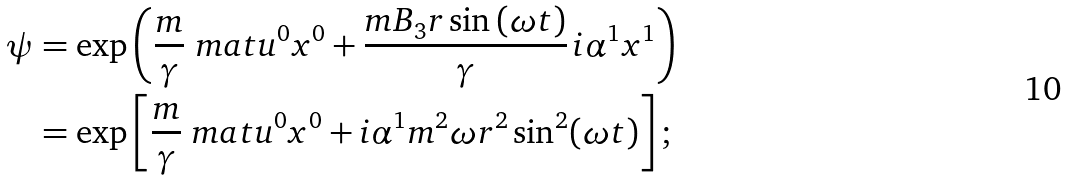<formula> <loc_0><loc_0><loc_500><loc_500>\psi & = \exp \left ( \frac { m } { \gamma } \ m a t { u } ^ { 0 } x ^ { 0 } + \frac { m B _ { 3 } r \sin \left ( \omega t \right ) } { \gamma } \, i \alpha ^ { 1 } x ^ { 1 } \right ) \\ & = \exp \left [ \frac { m } { \gamma } \ m a t { u } ^ { 0 } x ^ { 0 } + i \alpha ^ { 1 } m ^ { 2 } \omega r ^ { 2 } \sin ^ { 2 } ( \omega t ) \right ] ;</formula> 